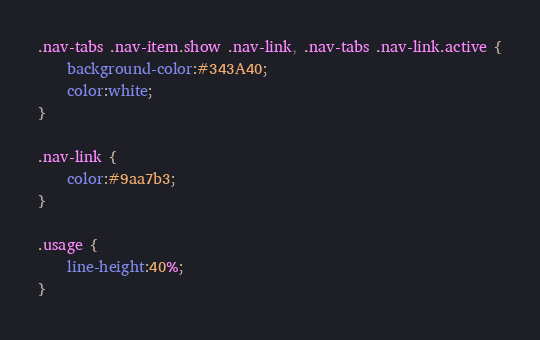<code> <loc_0><loc_0><loc_500><loc_500><_CSS_>.nav-tabs .nav-item.show .nav-link, .nav-tabs .nav-link.active {
    background-color:#343A40;
    color:white;
}

.nav-link {
    color:#9aa7b3;
}

.usage {
    line-height:40%;
}</code> 